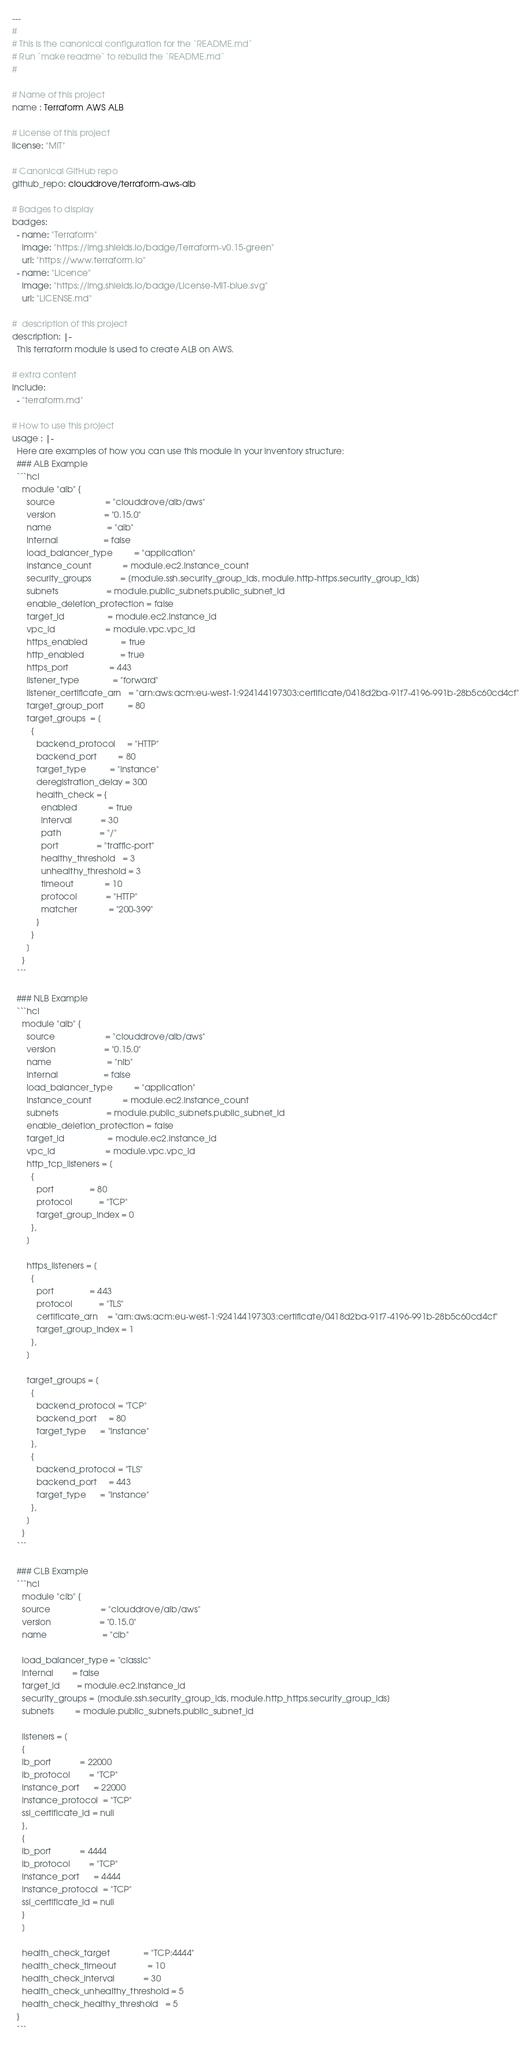Convert code to text. <code><loc_0><loc_0><loc_500><loc_500><_YAML_>---
#
# This is the canonical configuration for the `README.md`
# Run `make readme` to rebuild the `README.md`
#

# Name of this project
name : Terraform AWS ALB

# License of this project
license: "MIT"

# Canonical GitHub repo
github_repo: clouddrove/terraform-aws-alb

# Badges to display
badges:
  - name: "Terraform"
    image: "https://img.shields.io/badge/Terraform-v0.15-green"
    url: "https://www.terraform.io"
  - name: "Licence"
    image: "https://img.shields.io/badge/License-MIT-blue.svg"
    url: "LICENSE.md"

#  description of this project
description: |-
  This terraform module is used to create ALB on AWS.

# extra content
include:
  - "terraform.md"

# How to use this project
usage : |-
  Here are examples of how you can use this module in your inventory structure:
  ### ALB Example
  ```hcl
    module "alb" {
      source                     = "clouddrove/alb/aws"
      version                    = "0.15.0"
      name                       = "alb"
      internal                   = false
      load_balancer_type         = "application"
      instance_count             = module.ec2.instance_count
      security_groups            = [module.ssh.security_group_ids, module.http-https.security_group_ids]
      subnets                    = module.public_subnets.public_subnet_id
      enable_deletion_protection = false
      target_id                  = module.ec2.instance_id
      vpc_id                     = module.vpc.vpc_id
      https_enabled              = true
      http_enabled               = true
      https_port                 = 443
      listener_type              = "forward"
      listener_certificate_arn   = "arn:aws:acm:eu-west-1:924144197303:certificate/0418d2ba-91f7-4196-991b-28b5c60cd4cf"
      target_group_port          = 80
      target_groups  = [
        {
          backend_protocol     = "HTTP"
          backend_port         = 80
          target_type          = "instance"
          deregistration_delay = 300
          health_check = {
            enabled             = true
            interval            = 30
            path                = "/"
            port                = "traffic-port"
            healthy_threshold   = 3
            unhealthy_threshold = 3
            timeout             = 10
            protocol            = "HTTP"
            matcher             = "200-399"
          }
        }
      ]
    }
  ```

  ### NLB Example
  ```hcl
    module "alb" {
      source                     = "clouddrove/alb/aws"
      version                    = "0.15.0"
      name                       = "nlb"
      internal                   = false
      load_balancer_type         = "application"
      instance_count             = module.ec2.instance_count
      subnets                    = module.public_subnets.public_subnet_id
      enable_deletion_protection = false
      target_id                  = module.ec2.instance_id
      vpc_id                     = module.vpc.vpc_id
      http_tcp_listeners = [
        {
          port               = 80
          protocol           = "TCP"
          target_group_index = 0
        },
      ]

      https_listeners = [
        {
          port               = 443
          protocol           = "TLS"
          certificate_arn    = "arn:aws:acm:eu-west-1:924144197303:certificate/0418d2ba-91f7-4196-991b-28b5c60cd4cf"
          target_group_index = 1
        },
      ]

      target_groups = [
        {
          backend_protocol = "TCP"
          backend_port     = 80
          target_type      = "instance"
        },
        {
          backend_protocol = "TLS"
          backend_port     = 443
          target_type      = "instance"
        },
      ]
    }
  ```

  ### CLB Example
  ```hcl
    module "clb" {
    source                     = "clouddrove/alb/aws"
    version                    = "0.15.0"
    name                       = "clb"

    load_balancer_type = "classic"
    internal        = false
    target_id       = module.ec2.instance_id
    security_groups = [module.ssh.security_group_ids, module.http_https.security_group_ids]
    subnets         = module.public_subnets.public_subnet_id

    listeners = [
    {
    lb_port            = 22000
    lb_protocol        = "TCP"
    instance_port      = 22000
    instance_protocol  = "TCP"
    ssl_certificate_id = null
    },
    {
    lb_port            = 4444
    lb_protocol        = "TCP"
    instance_port      = 4444
    instance_protocol  = "TCP"
    ssl_certificate_id = null
    }
    ]

    health_check_target              = "TCP:4444"
    health_check_timeout             = 10
    health_check_interval            = 30
    health_check_unhealthy_threshold = 5
    health_check_healthy_threshold   = 5
  }
  ```
</code> 